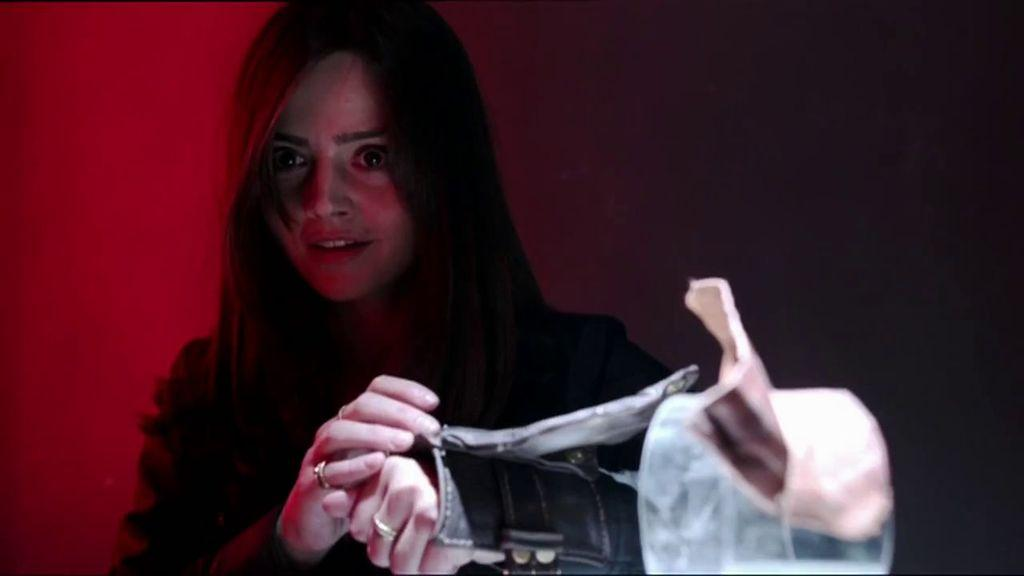Who is the main subject in the image? There is a woman in the image. What is located in front of the woman? There is an object in front of the woman. What color is the background of the image? The background of the image is red in color. What type of vegetable is the woman holding in the image? There is no vegetable present in the image. Can you tell me how many times the woman sneezes in the image? There is no indication of the woman sneezing in the image. 